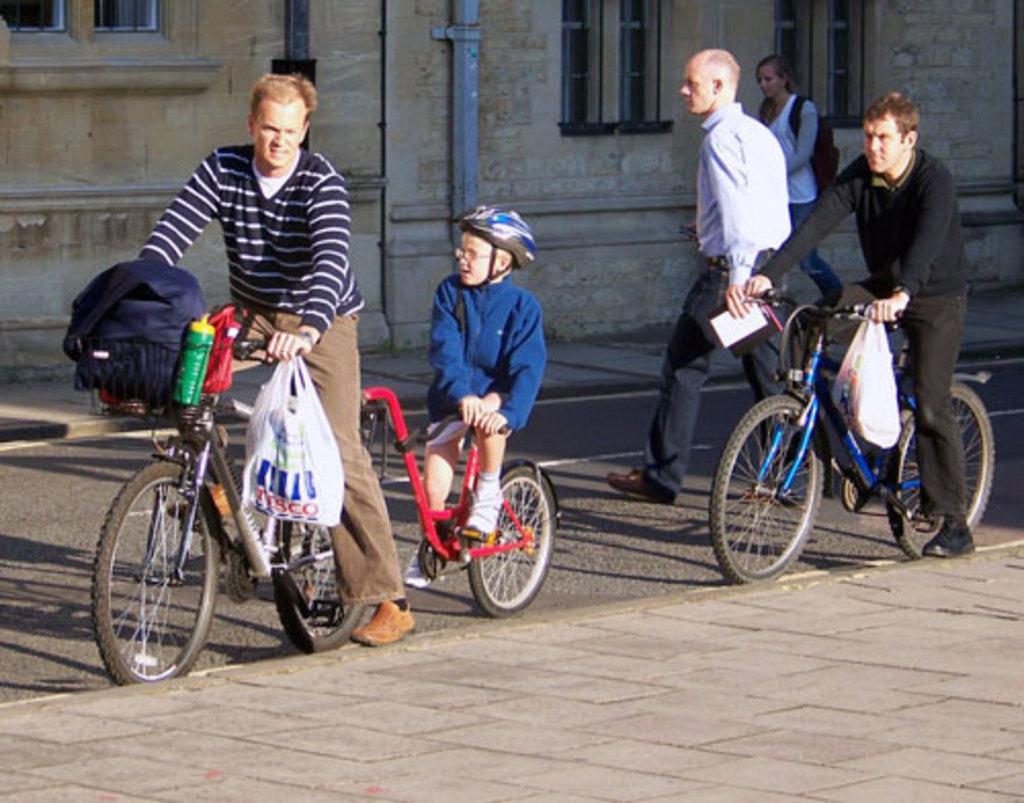Could you give a brief overview of what you see in this image? In this picture we can see man sitting on bicycle where we can see plastic cover, bottle are hanged to it and some persons are walking on road and foot path and in background we can see building with windows, pipes here boy sitting at back of the bicycle wore helmet. 